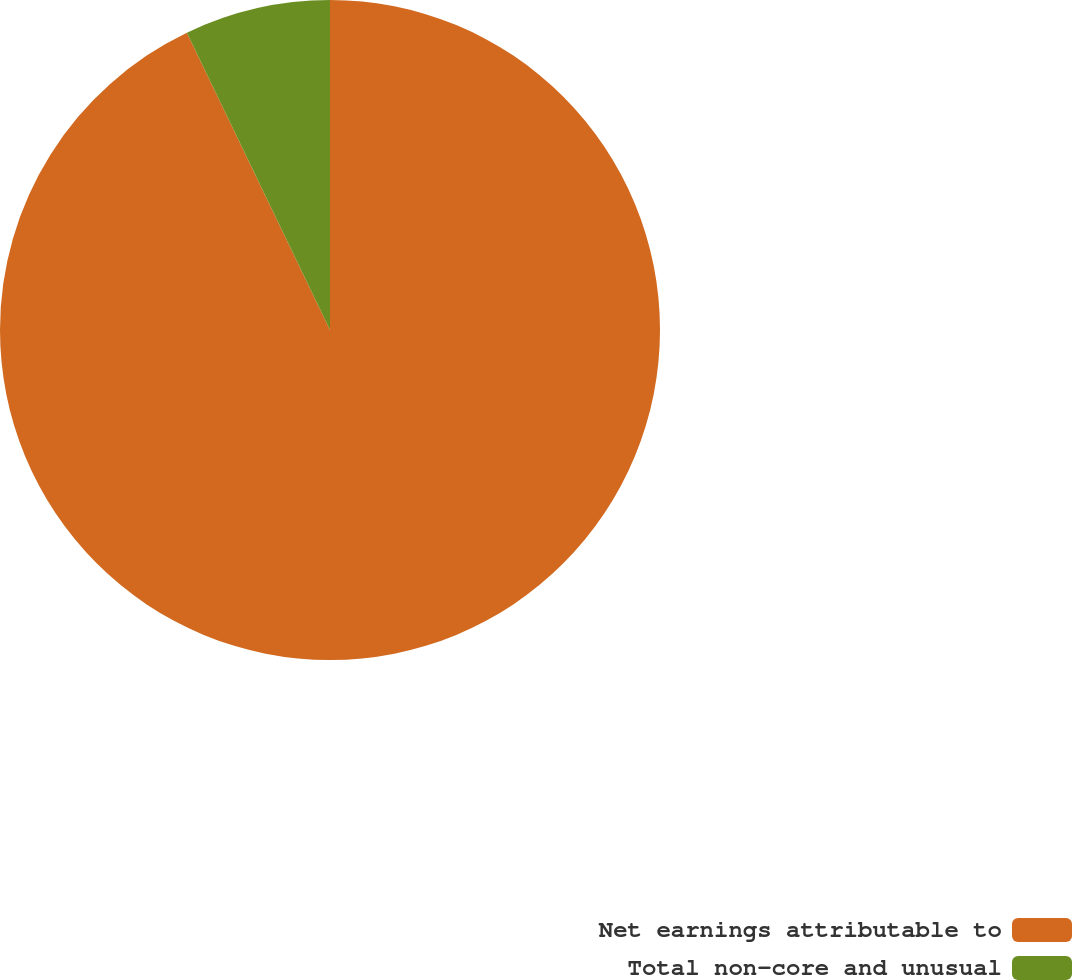Convert chart to OTSL. <chart><loc_0><loc_0><loc_500><loc_500><pie_chart><fcel>Net earnings attributable to<fcel>Total non-core and unusual<nl><fcel>92.86%<fcel>7.14%<nl></chart> 